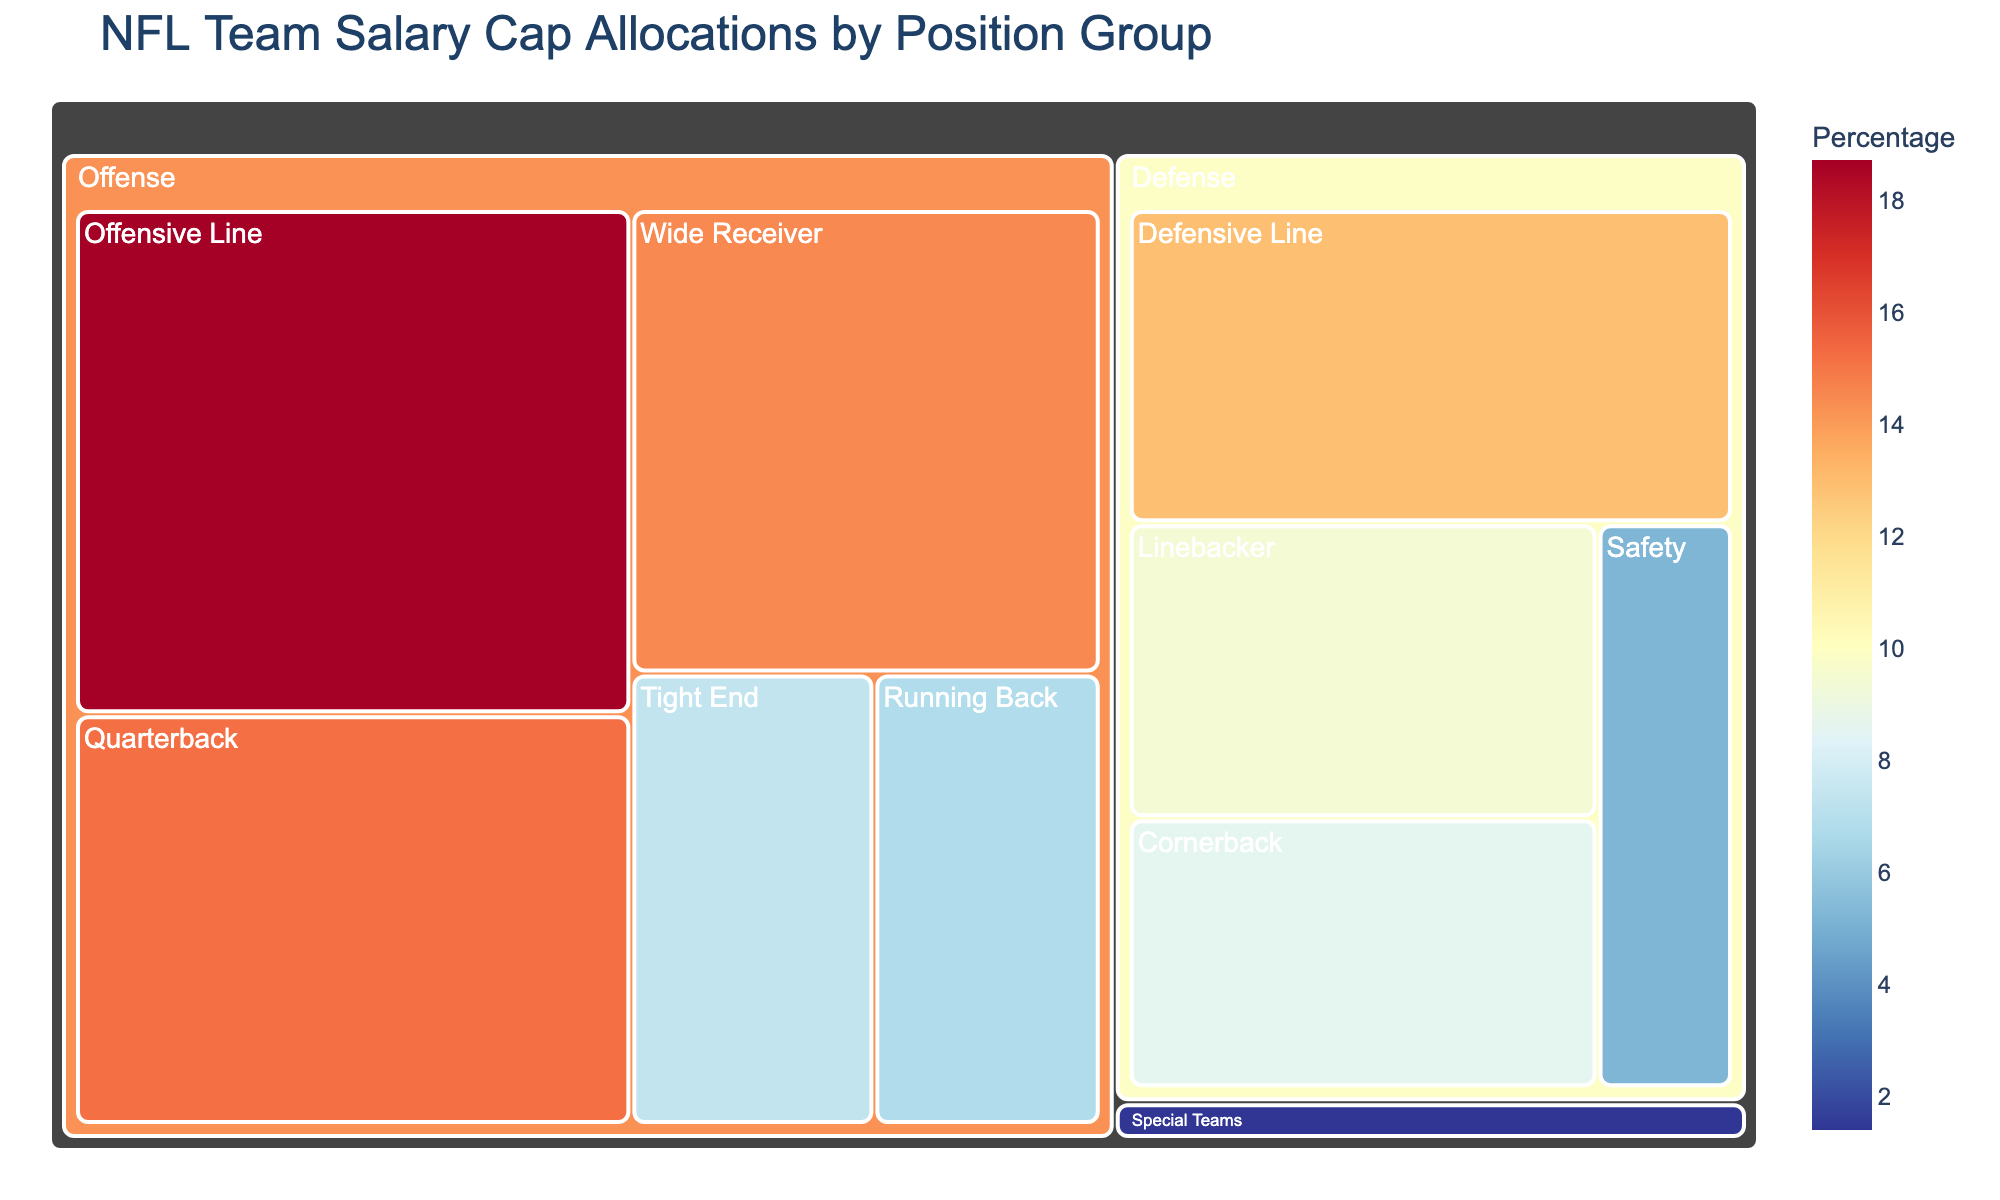what is the title of the figure? The title of a figure is a text element that typically appears at the top and summarizes the main topic of the visual. In this case, the title of the figure is "NFL Team Salary Cap Allocations by Position Group"
Answer: NFL Team Salary Cap Allocations by Position Group Which position group has the highest salary cap allocation? To determine the position group with the highest salary cap allocation, look for the largest section in the treemap. The "Offensive Line" section is notably the largest, with 18.7%.
Answer: Offensive Line What is the total percentage allocated to the offense positions? The total percentage allocated to offense positions can be found by summing the percentages of the Quarterback, Running Back, Wide Receiver, Tight End, and Offensive Line. Adding them gives: 15.2 + 6.8 + 14.5 + 7.3 + 18.7 = 62.5%
Answer: 62.5% Which positional group receives the least salary cap allocation? To identify the least funded positional group, look for the smallest section in the treemap. The "Special Teams" section is smallest with 1.4%.
Answer: Special Teams Are there more resources allocated to defense or offense? To determine if more resources are allocated to defense or offense, compare the sum of percentages for each. Offensive positions total 62.5%, and defensive positions (Defensive Line, Linebacker, Cornerback, Safety) total 12.9 + 9.4 + 8.6 + 5.2 = 36.1%. Therefore, offense receives more resources.
Answer: Offense How does the quarterback's percentage compare to the tight end's? Compare the percentage of the quarterback to that of the tight end. The quarterback is allocated 15.2%, whereas the tight end is allocated 7.3%. 15.2% is higher than 7.3%.
Answer: Higher Which position within defense has the highest allocation and what is its value? Identify the highest allocated position within the defense group by finding the largest section in that subgroup. "Defensive Line" has the highest percentage with 12.9%.
Answer: Defensive Line, 12.9% What is the difference in allocation between Wide Receiver and Linebacker groups? Calculate the allocation difference between Wide Receiver (14.5%) and Linebacker (9.4%) by subtracting the smaller percentage from the larger one. 14.5% - 9.4% = 5.1%
Answer: 5.1% What color is typically associated with the highest percentages on the treemap? The highest percentages on the treemap are indicated by the color scale, which uses color to represent data. In this case, higher percentages are represented with red tones due to the specified color scale (px.colors.diverging.RdYlBu).
Answer: Red Which areas would you assess to review the investment in secondary defense positions? Evaluating the investment in secondary defense involves examining the "Cornerback" and "Safety" sections within the treemap. Cornerback is allocated 8.6% and Safety is allocated 5.2%. Both sections must be reviewed.
Answer: Cornerback and Safety 